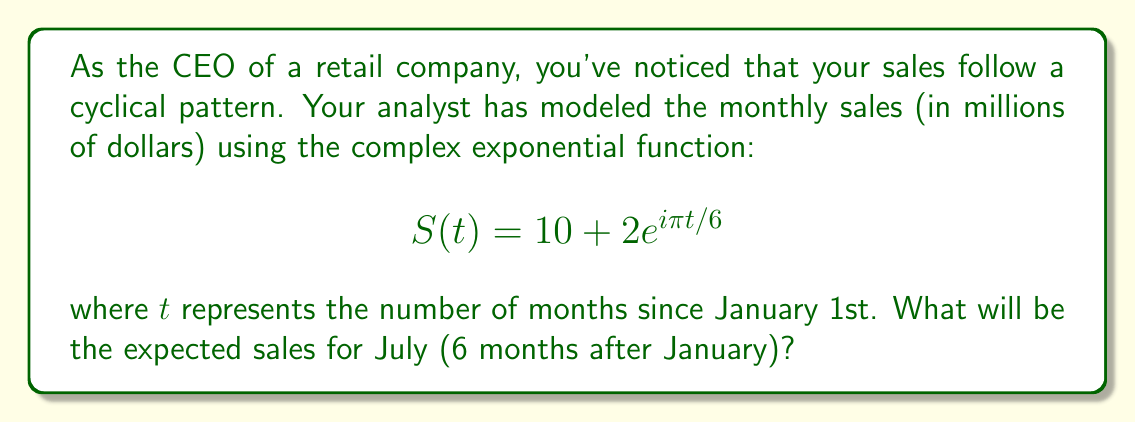Provide a solution to this math problem. To solve this problem, we'll follow these steps:

1) We need to evaluate $S(t)$ at $t = 6$ (July is 6 months after January).

2) Let's substitute $t = 6$ into the given function:

   $$S(6) = 10 + 2e^{i\pi 6/6}$$

3) Simplify the exponent:

   $$S(6) = 10 + 2e^{i\pi}$$

4) Recall Euler's formula: $e^{i\pi} = -1$

5) Apply this to our equation:

   $$S(6) = 10 + 2(-1)$$

6) Simplify:

   $$S(6) = 10 - 2 = 8$$

Therefore, the expected sales for July will be 8 million dollars.

This cyclical pattern repeats every 12 months (when $t$ increases by 12, the exponent increases by $2\pi$, completing a full cycle), which aligns with the annual business cycle often observed in retail.
Answer: $8 million 